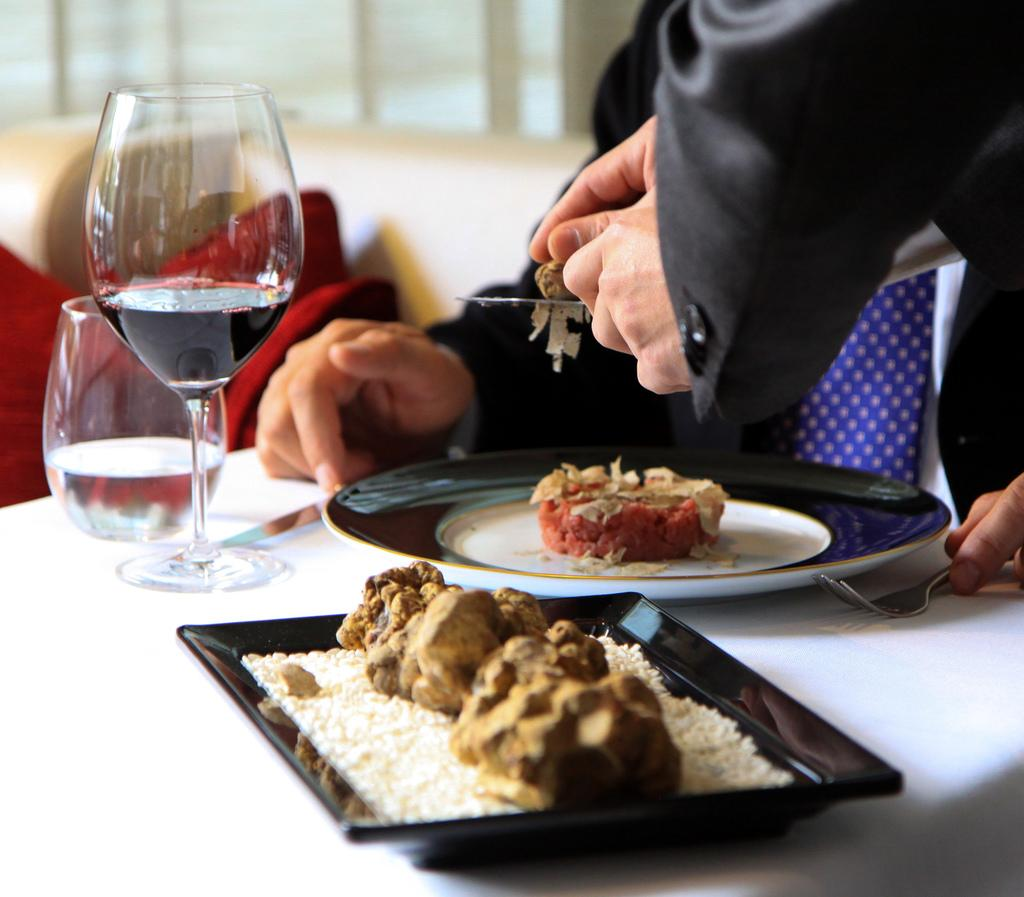How many people are in the image? There are two persons in the image. What is present in the image besides the people? There is a table in the image. What can be found on the table? There are plates, food items, and glasses on the table. What type of beam is holding up the ceiling in the image? There is no beam visible in the image; it does not show the ceiling or any structural elements. 